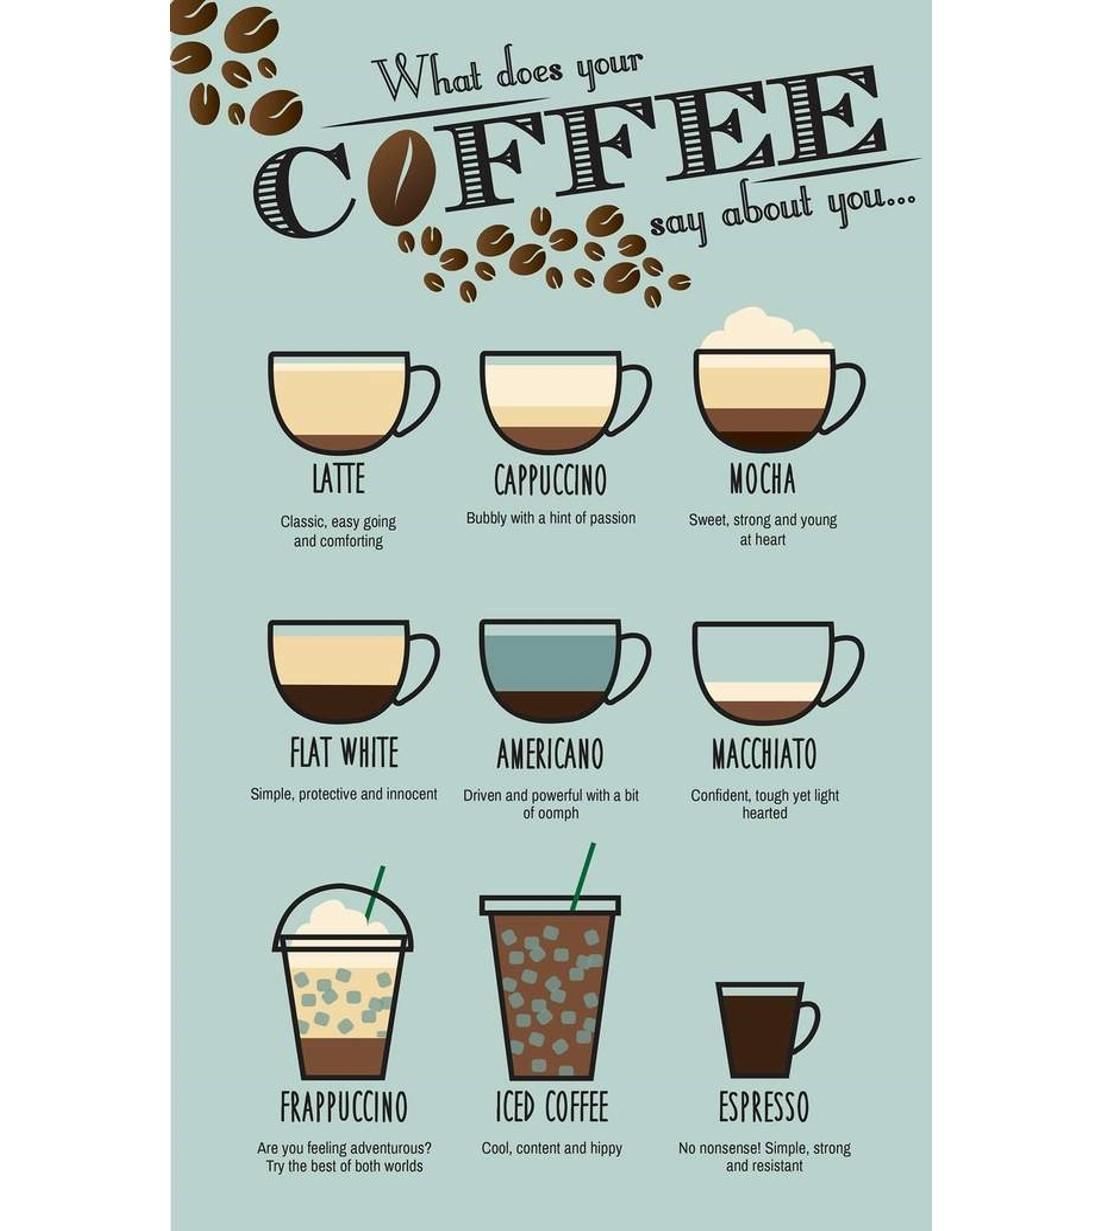How many types of coffee are mentioned?
Answer the question with a short phrase. 9 